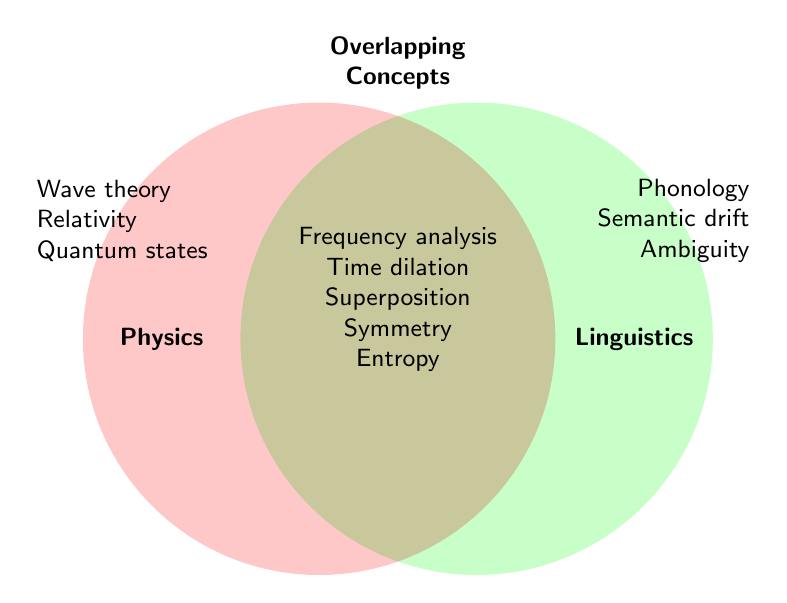How many concepts are in the overlapping area? The overlapping area lists five concepts as seen in the central part of the diagram: Frequency analysis, Time dilation, Superposition, Symmetry, and Entropy.
Answer: 5 What concept in physics is associated with "Phonology" in linguistics? "Phonology" appears in the linguistics section on the right, but we need to check for related content in physics. The overlapping concept "Frequency analysis" connects both categories.
Answer: Wave theory Which field discusses "Entropy" in the context of communication? "Entropy" is listed in the physics section and also falls under the overlapping concepts, relating it to "Information theory" in linguistics.
Answer: Both Physics and Linguistics Which field deals with "Time dilation"? "Time dilation" is mentioned as one of the common concepts between the fields, so it must be found in both physics and the overlapping area with linguistics.
Answer: Overlapping Concepts In how many ways can the concept of "Superposition" be interpreted based on the context? "Superposition" is an overlapping concept between physics and linguistics, indicating it can be interpreted in at least two ways: related to quantum states in physics and ambiguity in linguistics.
Answer: 2 Which field uniquely discusses "Syntax structure"? "Syntax structure" appears under linguistics on the right section and it does not show up in the physics or overlapping sections.
Answer: Linguistics What is the relationship between "Dark matter" and "Implicit meaning"? "Dark matter" from physics and "Implicit meaning" from linguistics both share the idea of "Hidden structures" as an overlapping concept.
Answer: Hidden structures Compare the concepts of "Relativity" in physics and "Semantic drift" in linguistics. What is their common overlapping concept? By referring to the overlapping area where both concepts meet, "Time dilation" can be seen as the connecting idea between "Relativity" and "Semantic drift."
Answer: Time dilation What quantitative measure appears in both "Wave theory" and "Phonology"? Both "Wave theory" from physics and "Phonology" from linguistics have their overlapping concept as "Frequency analysis", indicating a common quantitative measure.
Answer: Frequency analysis 